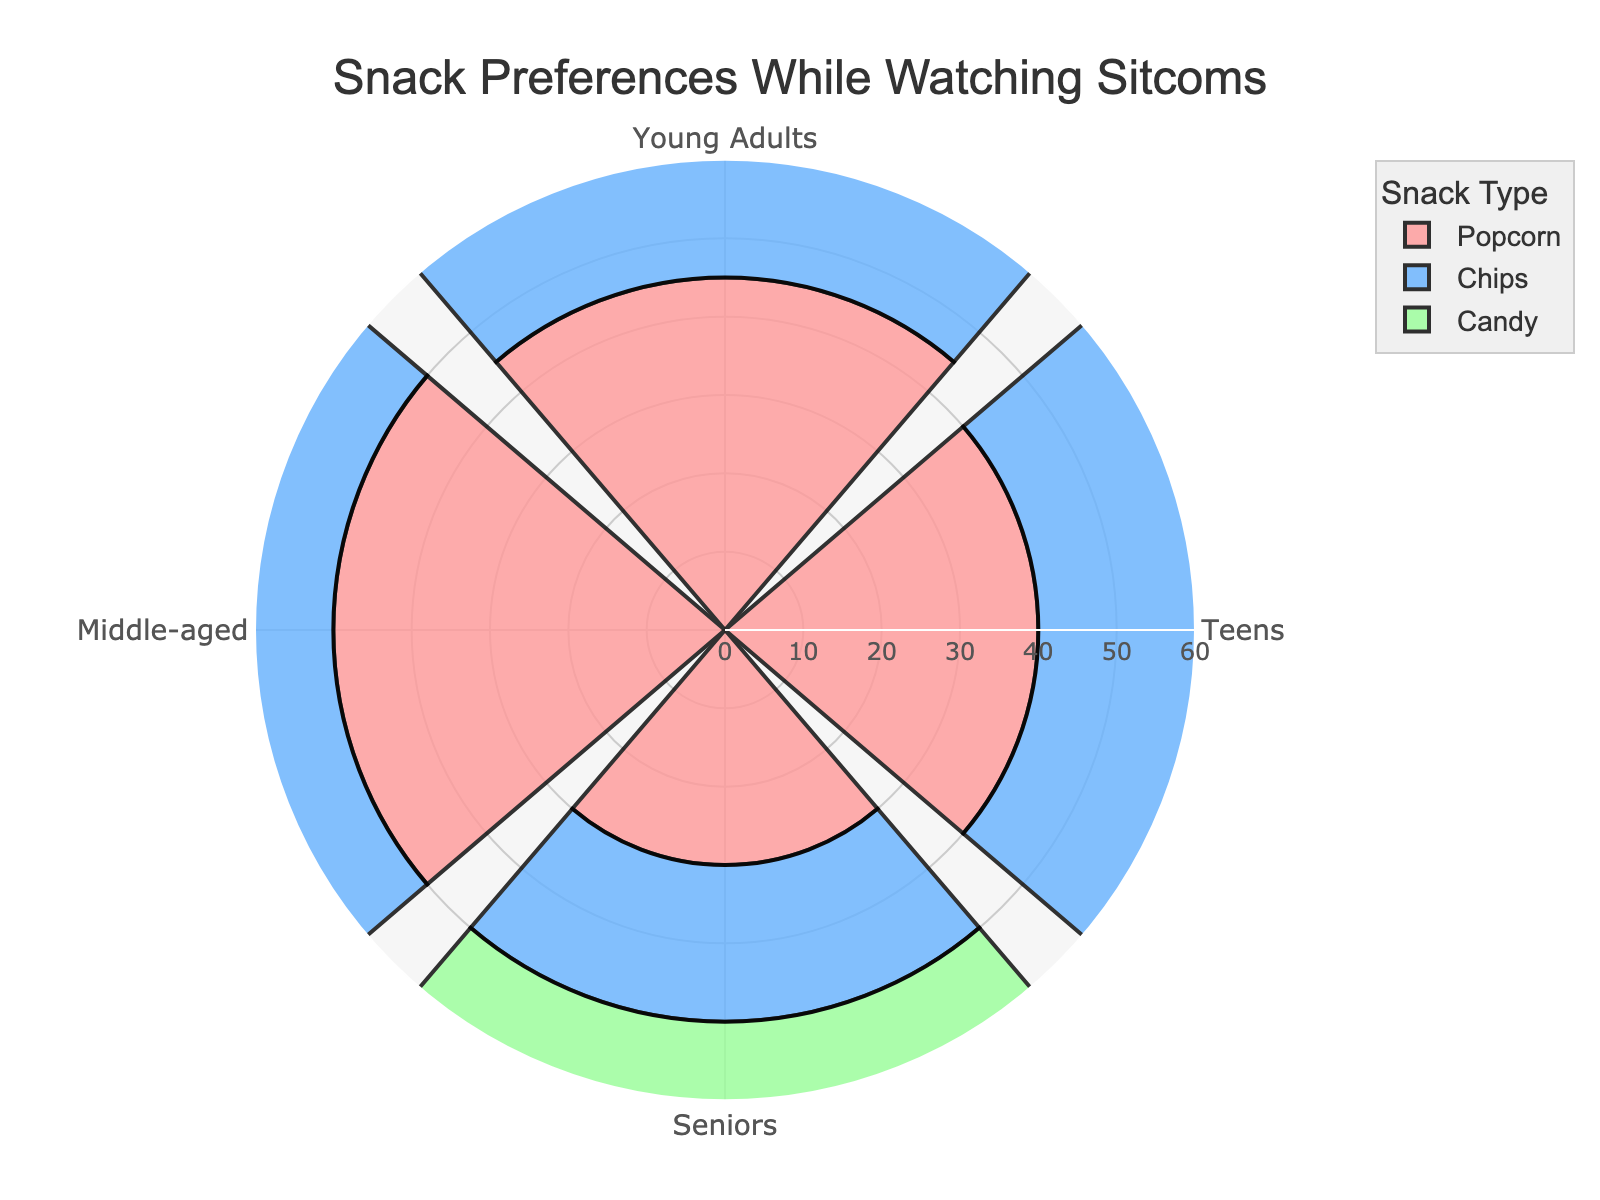What is the most preferred snack among middle-aged people? The rose chart shows the length of bars that represents the preference values. For middle-aged people, the longest bar corresponds to Popcorn.
Answer: Popcorn Which age group shows the highest preference for chips? By comparing the bars labeled "Chips" for each age group, we see that Teens have the longest bar.
Answer: Teens How many age groups have a higher preference for candy than chips? The Teens, Young Adults, and Middle-aged groups have chips higher than candy. Senior group has 35 for candy and 20 for chips. Just add and compare. You can see there's only one group that prefers candy more.
Answer: 1 Between popcorn and candy, which snack do seniors prefer more while watching sitcoms? For seniors, the bar representing their preference for popcorn is at 30, while for candy it is 35.
Answer: Candy What is the total preference value for candy across all age groups? Sum the values for candy from each age group: 15 (Teens) + 20 (Young Adults) + 15 (Middle-aged) + 35 (Seniors) = 85.
Answer: 85 Which snack has the lowest preference among young adults? The shortest bar for Young Adults corresponds to "Other" with a value of 5.
Answer: Other What is the difference in the preference for popcorn between the middle-aged group and the senior group? Subtract the value for seniors from the value for middle-aged: 50 (Middle-aged) - 30 (Seniors) = 20.
Answer: 20 Which age group has the most balanced preference across the three main snacks (popcorn, chips, candy)? Looking at the lengths of the bars, the Teens have values for popcorn (40), chips (35), and candy (15), which are closer in value compared to the other groups.
Answer: Teens What is the total preference value for all snacks by middle-aged people? Sum the values for a middle-aged group: 50 (Popcorn) + 25 (Chips) + 15 (Candy) + 10 (Other) = 100.
Answer: 100 Which snack type has the highest collective preference across all age groups? Sum the values for each snack type across the age groups:
Popcorn: 40 + 45 + 50 + 30 = 165
Chips: 35 + 30 + 25 + 20 = 110
Candy: 15 + 20 + 15 + 35 = 85
Popcorn has the highest collective value.
Answer: Popcorn 